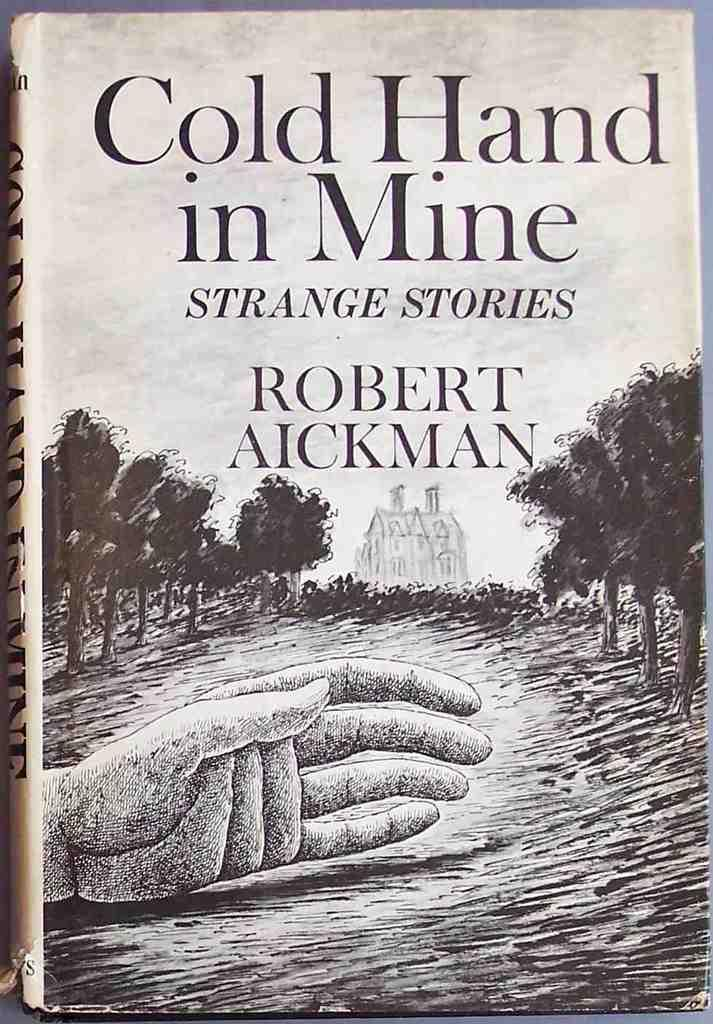<image>
Offer a succinct explanation of the picture presented. a copy of the book cold hand in mine. 